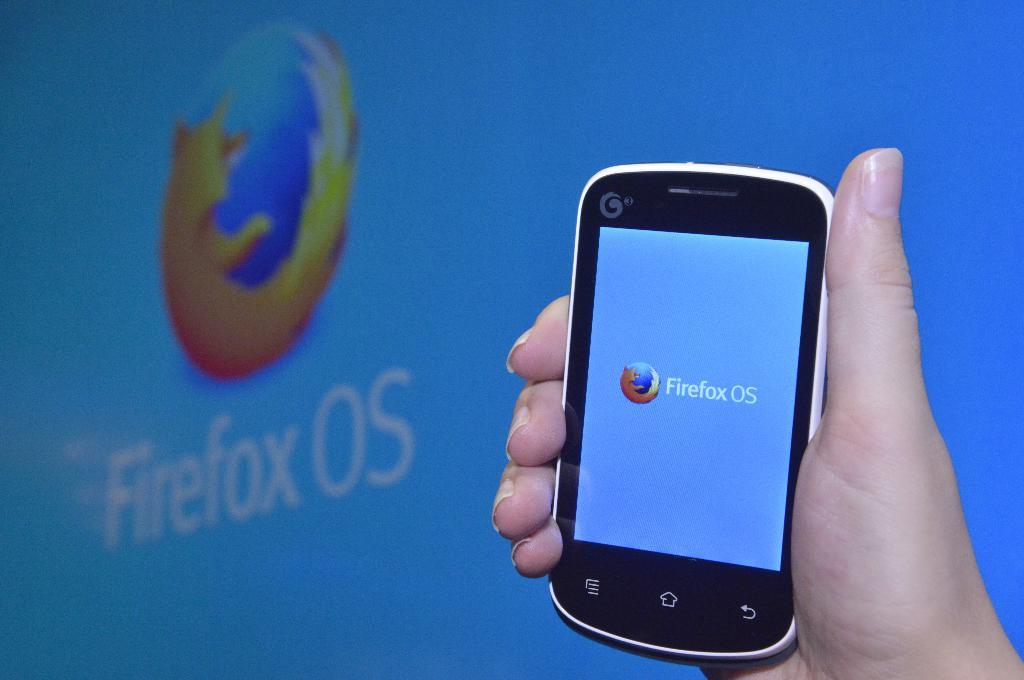Provide a one-sentence caption for the provided image. a phone that has the term Firefox on it. 